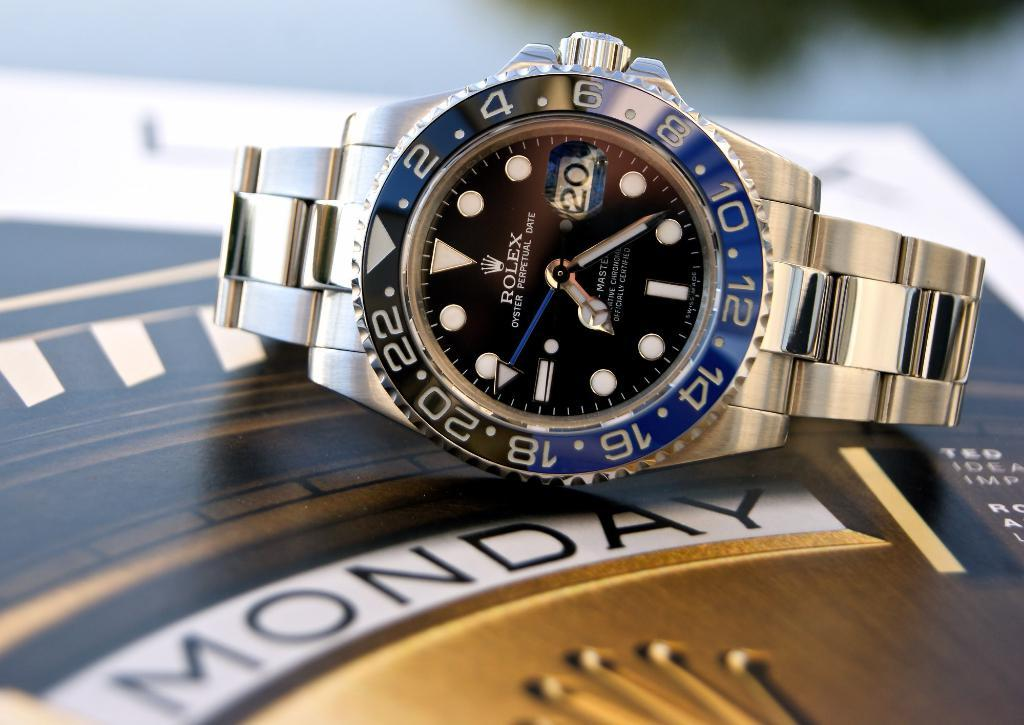<image>
Write a terse but informative summary of the picture. A gold 24-hour Rolex watch sets on a gold weekly tabletop clock labeled Monday. 